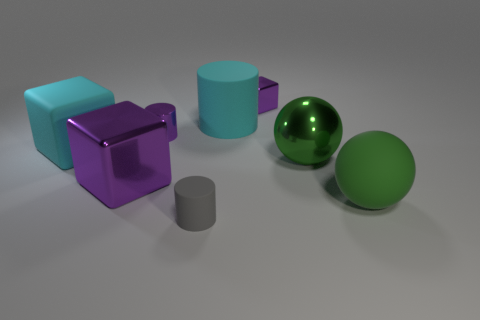Subtract all small shiny cubes. How many cubes are left? 2 Add 1 blue spheres. How many objects exist? 9 Subtract all cyan cylinders. How many cylinders are left? 2 Subtract all cylinders. How many objects are left? 5 Subtract all purple cylinders. How many purple cubes are left? 2 Subtract all blue shiny spheres. Subtract all cylinders. How many objects are left? 5 Add 2 large green objects. How many large green objects are left? 4 Add 2 big yellow cylinders. How many big yellow cylinders exist? 2 Subtract 0 yellow spheres. How many objects are left? 8 Subtract 2 blocks. How many blocks are left? 1 